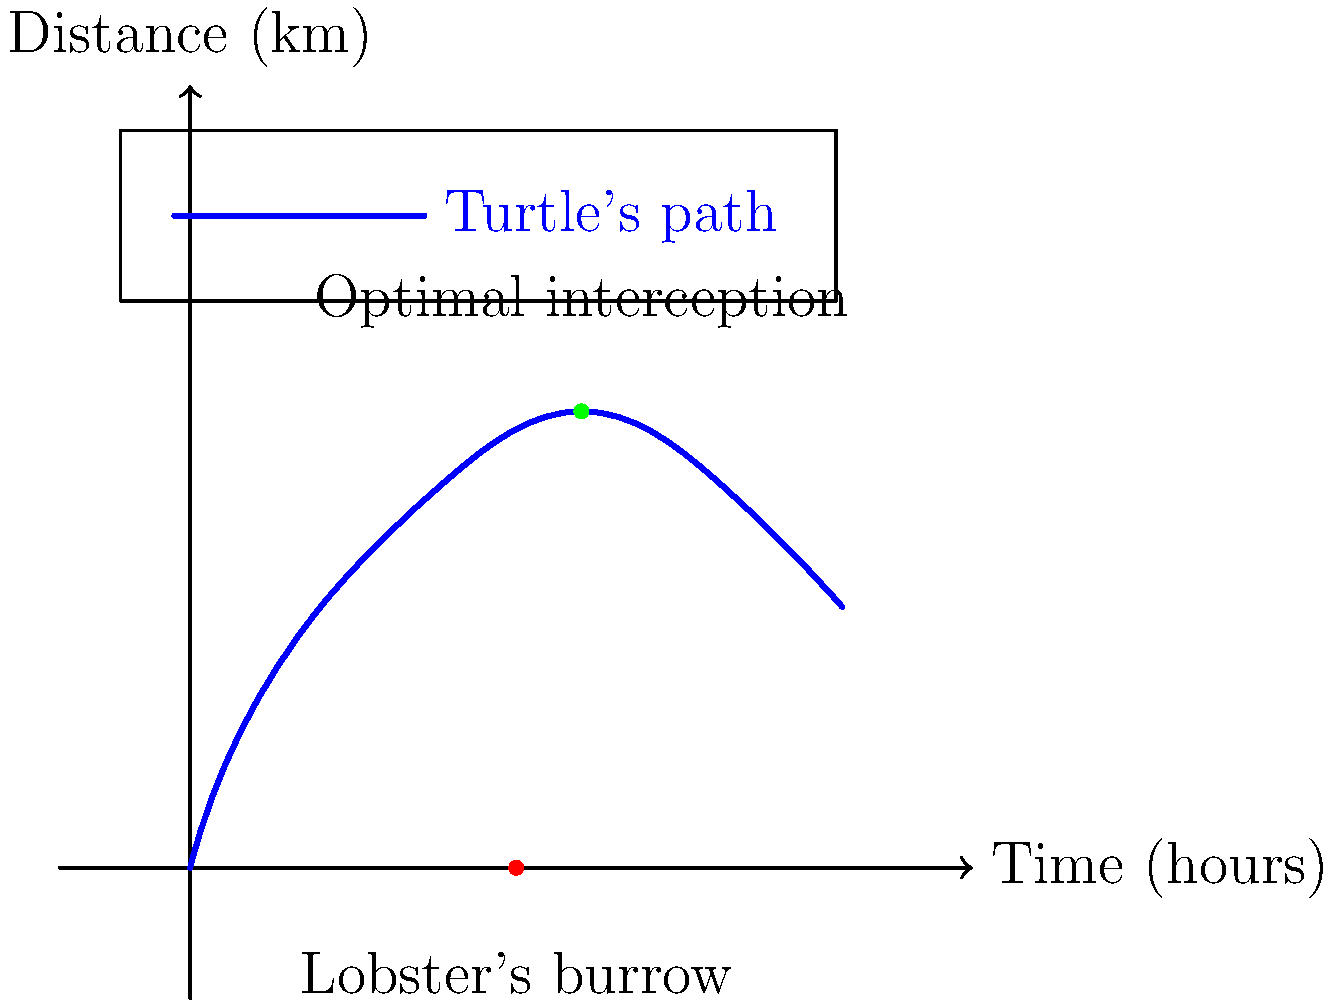A grumpy lobster is planning to surprise a sea turtle swimming above its burrow. The graph shows the turtle's swimming pattern over time. The lobster's burrow is located at the 2.5-hour mark on the time axis. If the lobster can travel at a speed of $0.5$ km/h in a straight line, at what time should it leave its burrow to intercept the turtle at the optimal point, assuming it wants to minimize its travel distance? To solve this problem, we need to follow these steps:

1) First, observe that the optimal interception point is at the highest point of the turtle's path, which occurs at t = 3 hours and a distance of 3.5 km.

2) Calculate the distance the lobster needs to travel:
   Distance = 3.5 km (vertical distance from x-axis to interception point)

3) Calculate the time the lobster needs to travel:
   Time = Distance / Speed
   Time = 3.5 km / 0.5 km/h = 7 hours

4) Calculate when the lobster should leave its burrow:
   Leave time = Interception time - Travel time
   Leave time = 3 hours - 7 hours = -4 hours

However, negative time doesn't make sense in this context. This means the lobster needs to start 4 hours before the beginning of our time scale to reach the interception point at the right moment.

5) Adjust the leave time to be within our time scale:
   Adjusted leave time = 0 hours (the earliest possible time in our scale)

6) Calculate how far the lobster can travel within the given time frame:
   Available time = 3 hours - 0 hours = 3 hours
   Distance traveled = Speed × Time = 0.5 km/h × 3 hours = 1.5 km

7) The lobster can only travel 1.5 km in the available time, which is not enough to reach the optimal interception point at 3.5 km.

8) Therefore, the lobster should leave its burrow at t = 0 to get as close as possible to the optimal interception point, even though it won't reach it in time.
Answer: 0 hours 